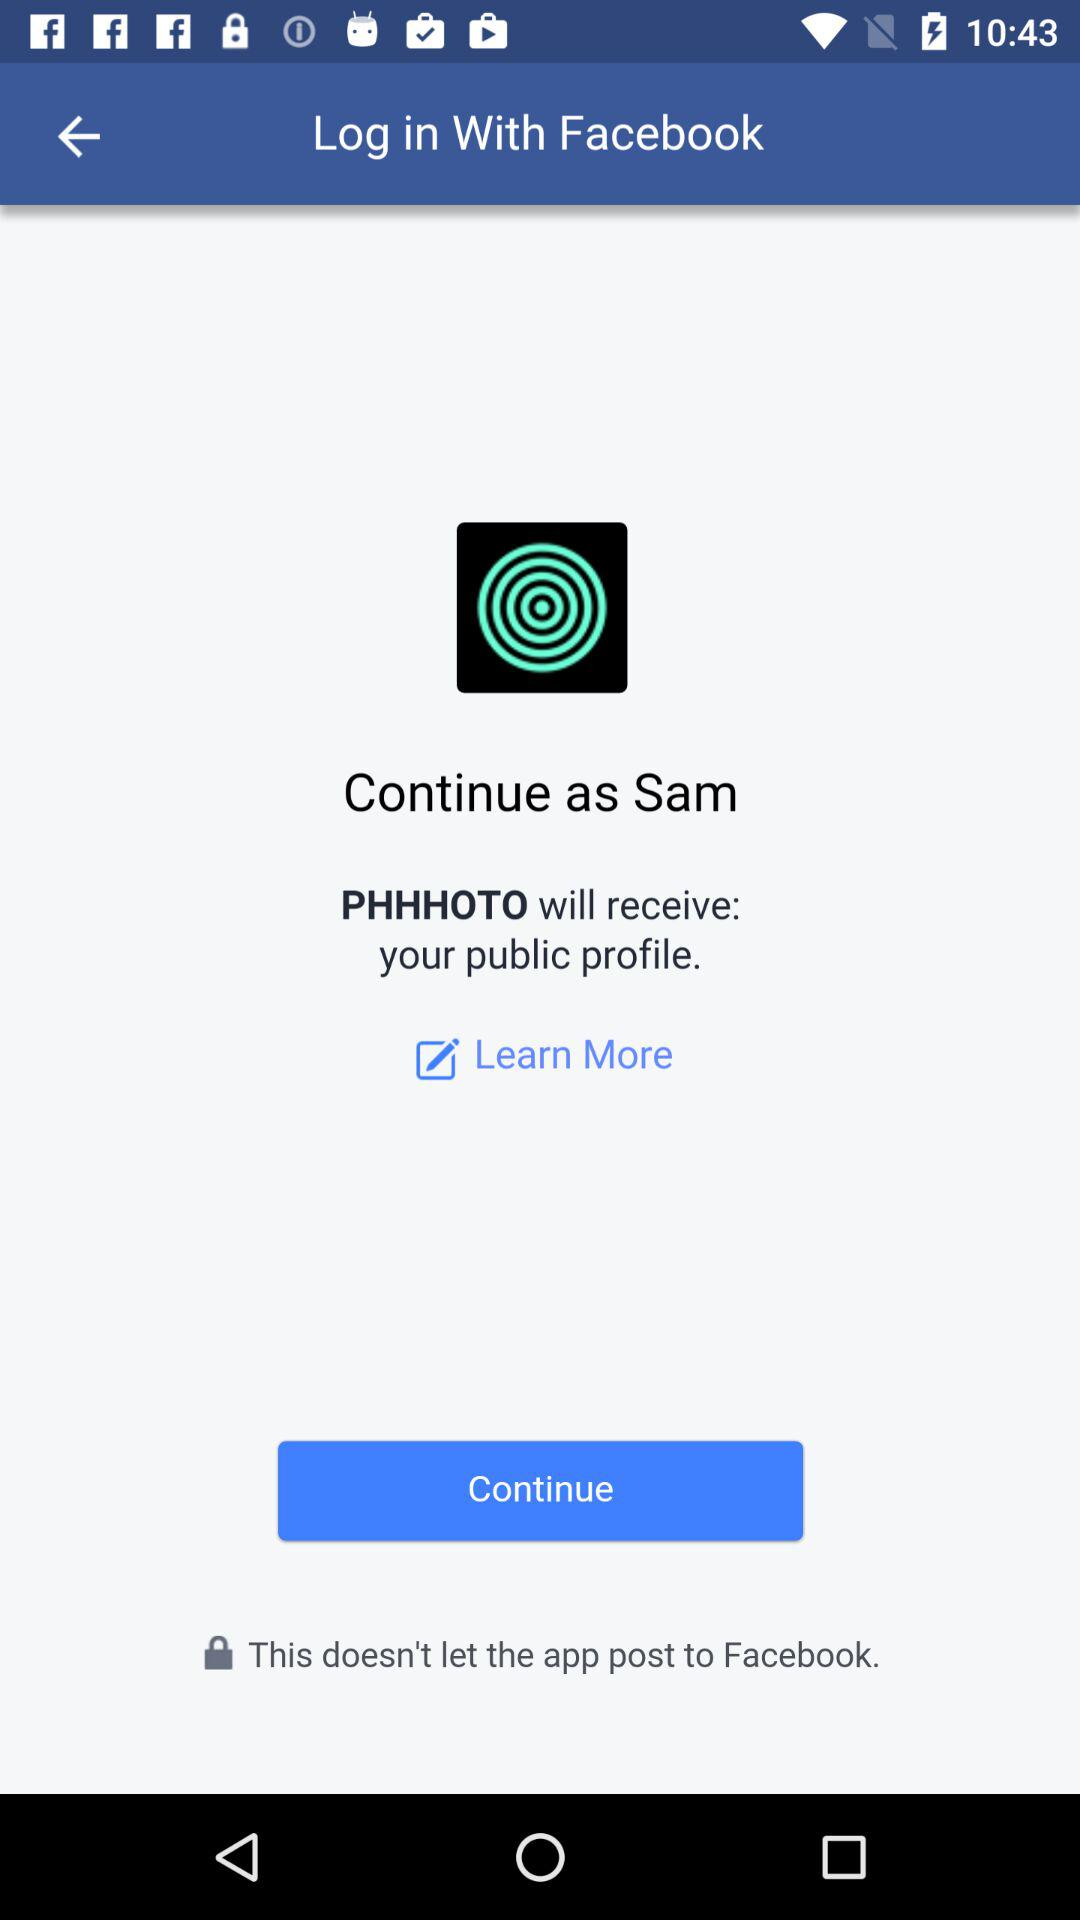What application will receive the public profile? The application is "PHHHOTO". 